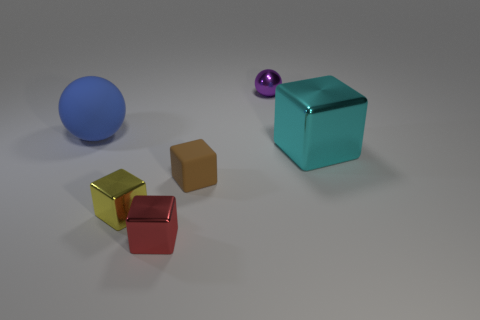Can you infer any relationship or pattern between the objects? There seems to be a deliberate arrangement of objects with a pattern of alternating colors and materials. The objects vary in size and color, suggesting diversity. The placement might imply a contrast between the reflective properties of the materials, as well as an exploration of geometric shapes, with spheres and cubes represented. 